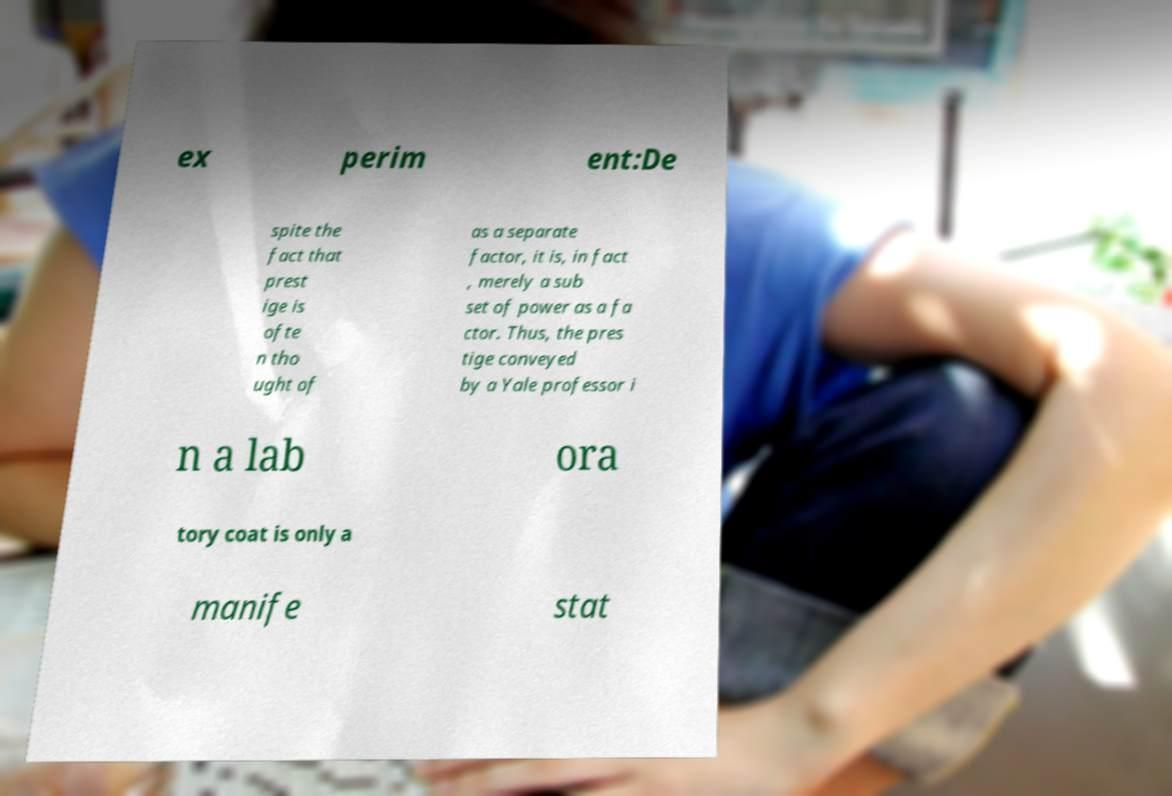What messages or text are displayed in this image? I need them in a readable, typed format. ex perim ent:De spite the fact that prest ige is ofte n tho ught of as a separate factor, it is, in fact , merely a sub set of power as a fa ctor. Thus, the pres tige conveyed by a Yale professor i n a lab ora tory coat is only a manife stat 